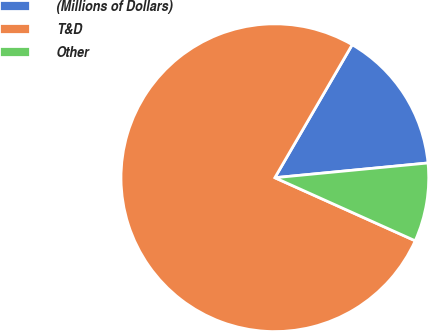<chart> <loc_0><loc_0><loc_500><loc_500><pie_chart><fcel>(Millions of Dollars)<fcel>T&D<fcel>Other<nl><fcel>15.09%<fcel>76.66%<fcel>8.25%<nl></chart> 